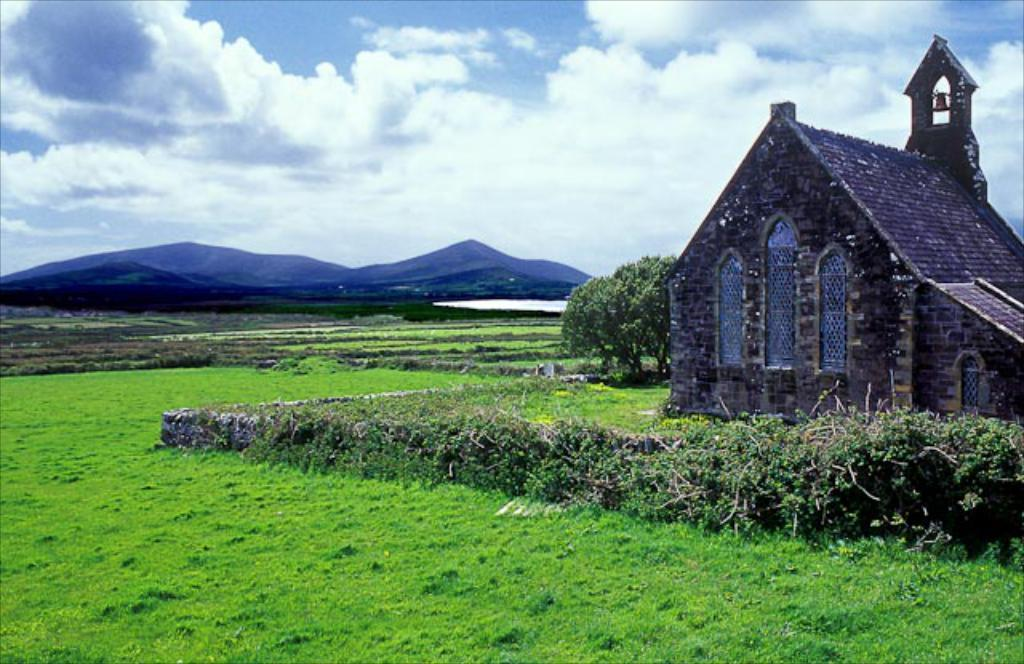What type of vegetation can be seen in the image? There is grass, plants, and trees visible in the image. What type of structures are present in the image? There are houses and farms visible in the image. What natural feature can be seen in the image? There are mountains visible in the image. What is the condition of the sky in the image? The sky is visible in the image. How many lizards can be seen crawling on the cobweb in the image? There are no lizards or cobwebs present in the image. What type of dance is being performed by the people in the image? There are no people or dancing activities depicted in the image. 